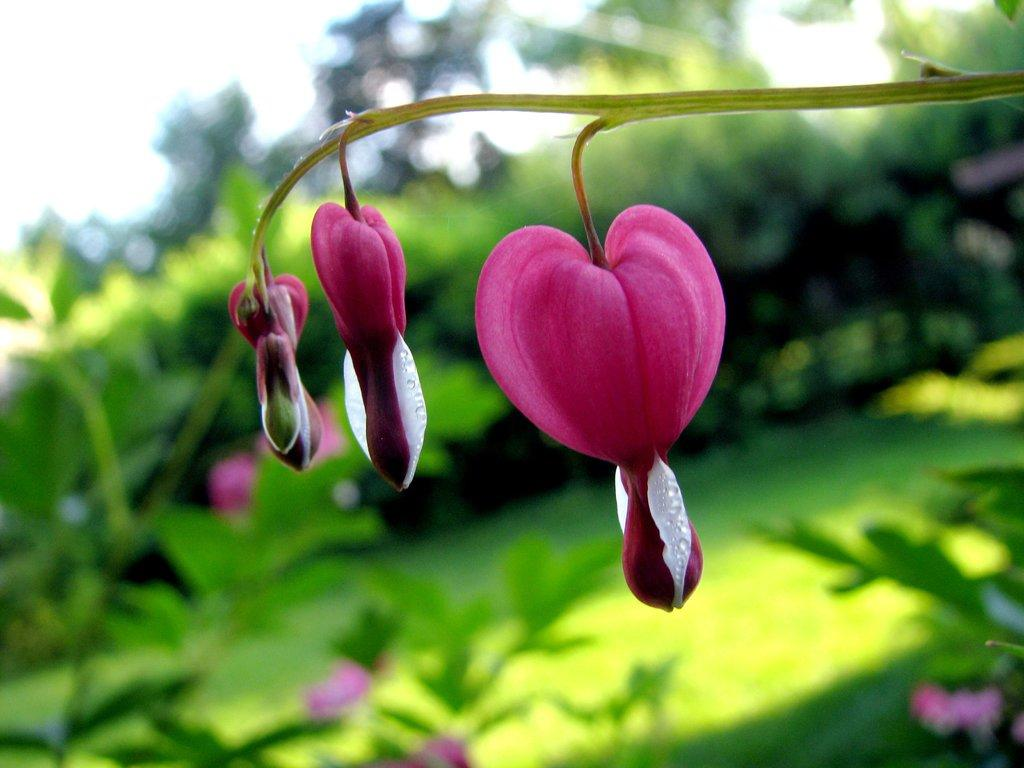What type of plant life can be seen in the image? There are buds, stems, grass, plants, and flowers visible in the image. What is the condition of the plants in the image? The plants in the image have buds and stems, indicating that they are growing. What type of vegetation is present in the image? There is grass and trees visible in the image. How is the background of the image depicted? The background of the image is blurred. What type of rock is being used as a quill to write on the plants in the image? There is no rock or quill present in the image, and the plants are not being written on. 